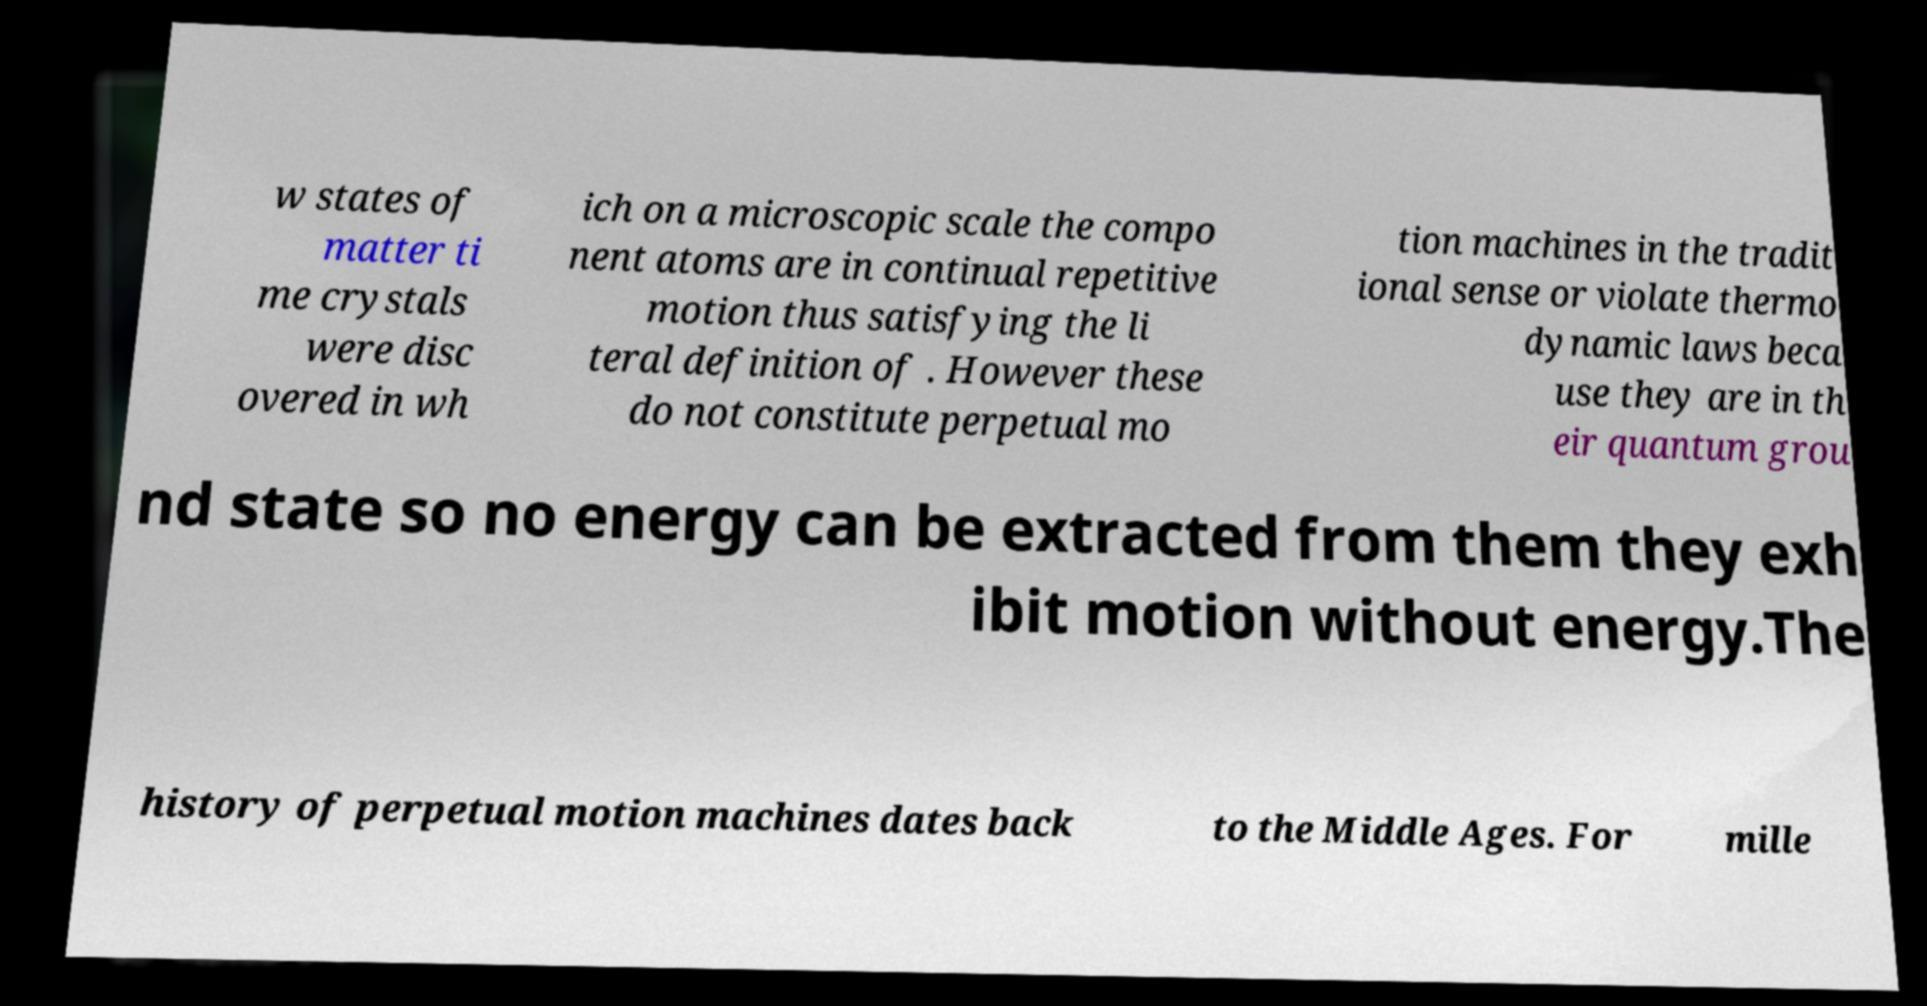Please identify and transcribe the text found in this image. w states of matter ti me crystals were disc overed in wh ich on a microscopic scale the compo nent atoms are in continual repetitive motion thus satisfying the li teral definition of . However these do not constitute perpetual mo tion machines in the tradit ional sense or violate thermo dynamic laws beca use they are in th eir quantum grou nd state so no energy can be extracted from them they exh ibit motion without energy.The history of perpetual motion machines dates back to the Middle Ages. For mille 